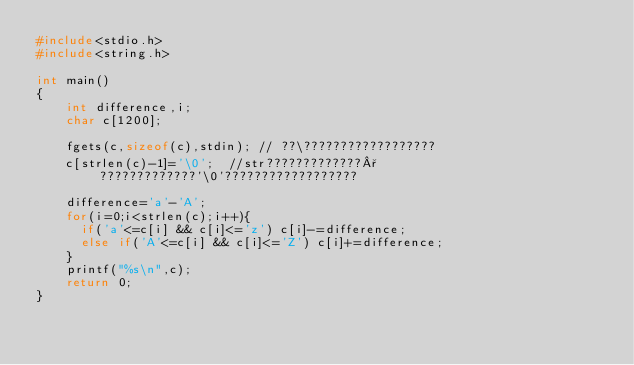<code> <loc_0><loc_0><loc_500><loc_500><_C_>#include<stdio.h>
#include<string.h>

int main()
{
    int difference,i;
    char c[1200];

    fgets(c,sizeof(c),stdin); // ??\??????????????????
    c[strlen(c)-1]='\0';  //str?????????????°?????????????'\0'??????????????????

    difference='a'-'A';
    for(i=0;i<strlen(c);i++){
      if('a'<=c[i] && c[i]<='z') c[i]-=difference;
      else if('A'<=c[i] && c[i]<='Z') c[i]+=difference;
    }
    printf("%s\n",c);
    return 0;
}</code> 